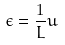Convert formula to latex. <formula><loc_0><loc_0><loc_500><loc_500>\epsilon = \frac { 1 } { L } u</formula> 